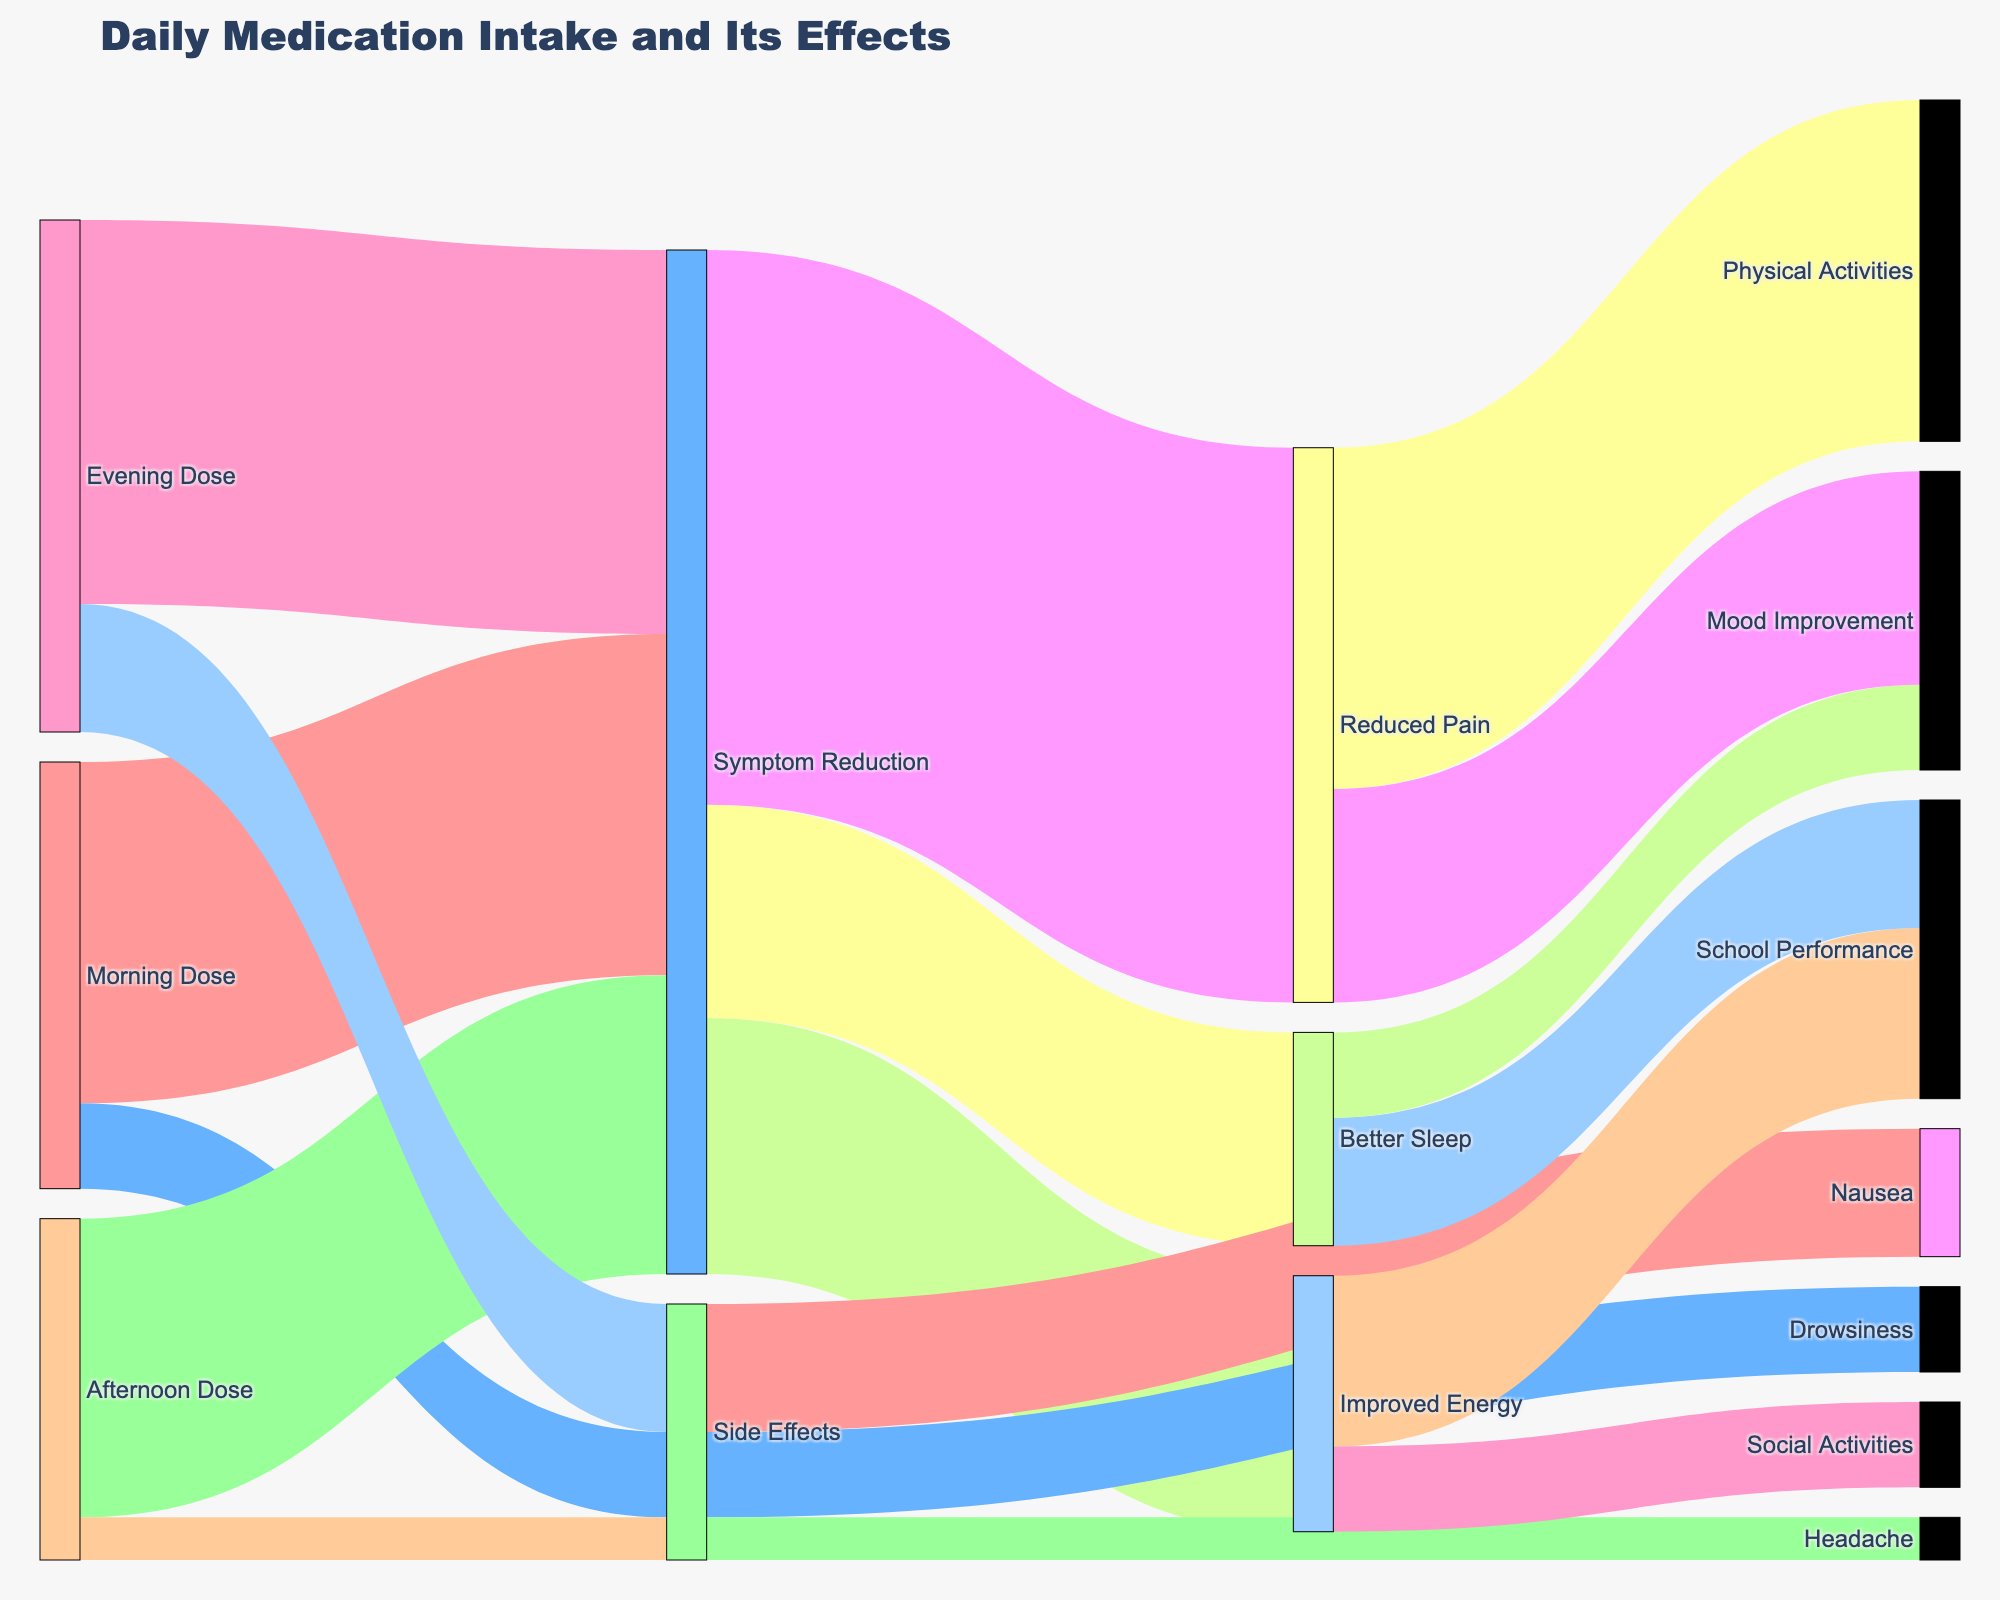What is the title of the figure? The title is displayed at the top center of the figure and is usually larger in font size than the rest of the text. The title indicates the main subject of the visualization.
Answer: Daily Medication Intake and Its Effects Which dose has the highest occurrence of symptom reduction? Look at the nodes connected to "Symptom Reduction" and evaluate the values. The highest value represents the dose with the most effective symptom reduction.
Answer: Evening Dose How many distinct symptoms are reduced due to medication? Look at the nodes connected to "Symptom Reduction" and count each unique resultant condition, such as Improved Energy, Better Sleep, and Reduced Pain.
Answer: Three symptoms What is the total value for symptom reduction from all doses? Sum the values of "Morning Dose", "Afternoon Dose", and "Evening Dose" that connect to "Symptom Reduction". The individual values are 40, 35, and 45 respectively. Calculate the total.
Answer: 40 + 35 + 45 = 120 Which side effect has the lowest value? Examine the values connected to the "Side Effects" node. Identify which has the smallest associated value.
Answer: Headache What combined effect does "Reduced Pain" have on "Physical Activities" and "Mood Improvement"? Look at the values connected from "Reduced Pain" to its subsequent nodes. Add the values from "Physical Activities" and "Mood Improvement".
Answer: 40 + 25 = 65 Compare the total values of side effects versus the symptom benefits. Which is greater? Sum the values for all side effects (Nausea, Drowsiness, Headache) and compare to the combined value for all symptom reductions. Side effects: 15 + 10 + 5 = 30. Symptom benefits: 120. Compare the sums.
Answer: Symptom benefits are greater How does "Improved Energy" link to other activities, and what are their values? Look at the nodes connected to "Improved Energy" and note each resulting condition and its associated value (School Performance, Social Activities).
Answer: School Performance: 20, Social Activities: 10 What is the difference in side effects between Morning and Evening Doses? Locate the values connected to "Side Effects" for both doses. Morning Dose has 10, and Evening Dose has 15. Calculate the difference.
Answer: 15 - 10 = 5 How is "Better Sleep" distributed among its resulting benefits? Look at the values connected from "Better Sleep" and note each resultant value (School Performance, Mood Improvement).
Answer: School Performance: 15, Mood Improvement: 10 